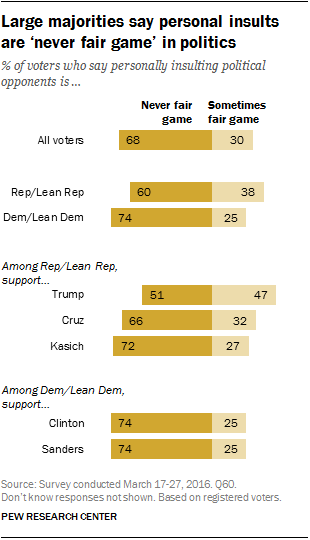Give some essential details in this illustration. The combined percentage of supporters of Trump's and Cruz's that think insulting is fair game is 0.79. Donald Trump's supporters believe that insulting is fair game for them. 